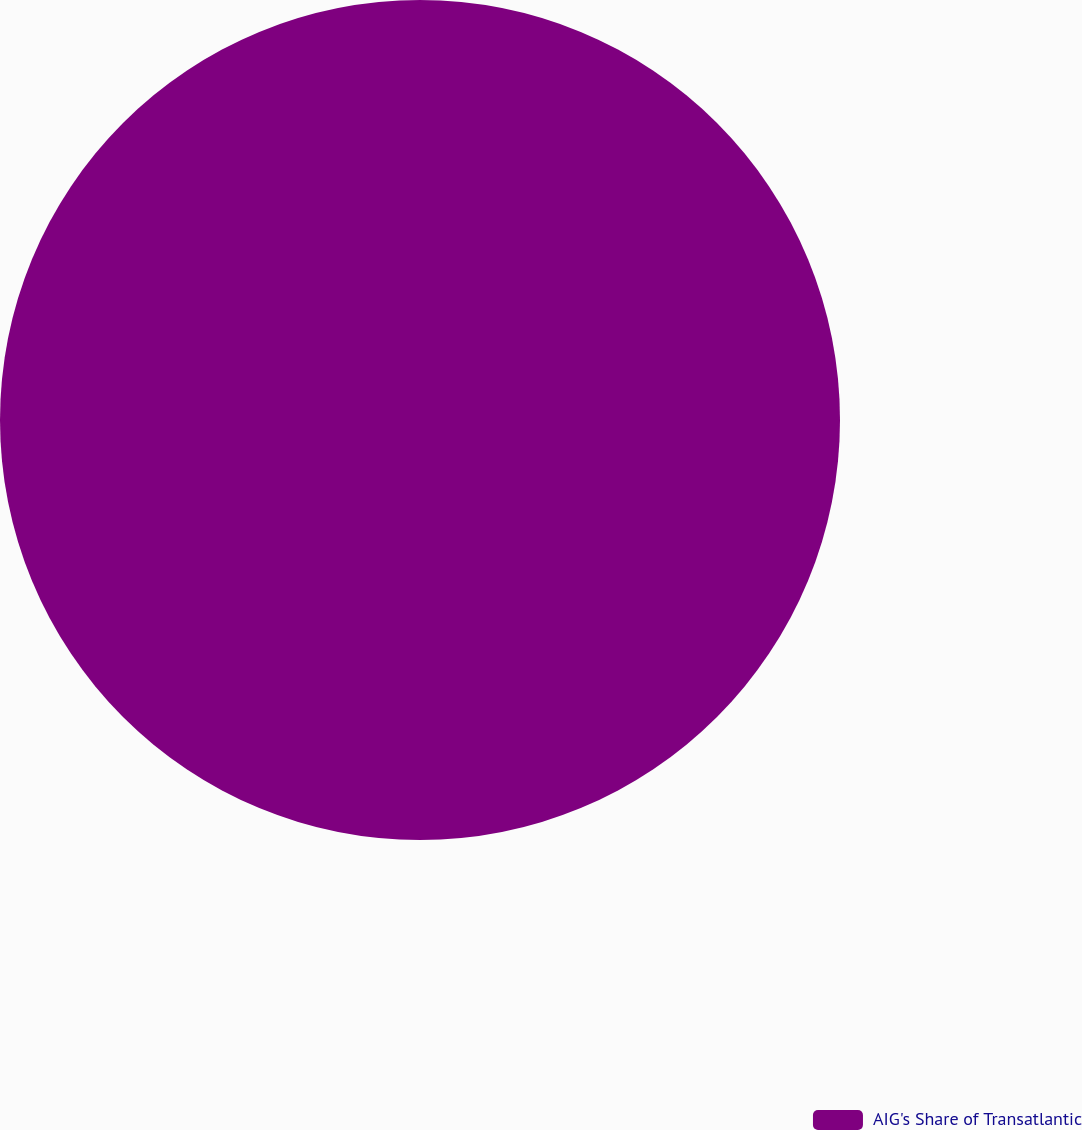Convert chart to OTSL. <chart><loc_0><loc_0><loc_500><loc_500><pie_chart><fcel>AIG's Share of Transatlantic<nl><fcel>100.0%<nl></chart> 